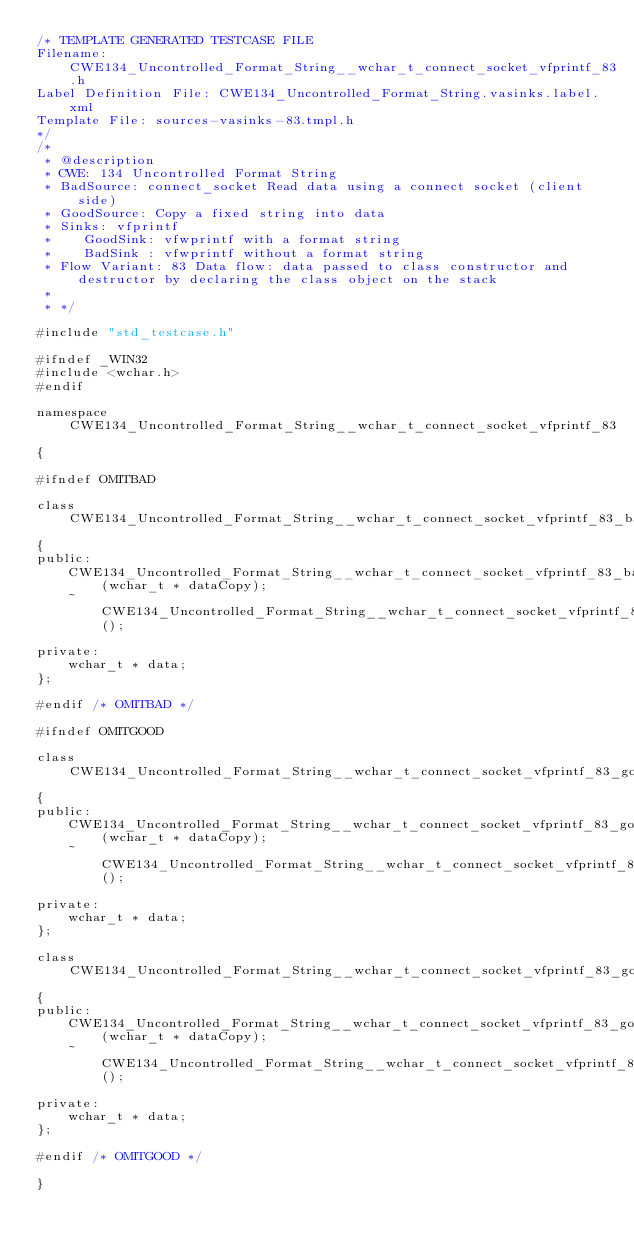<code> <loc_0><loc_0><loc_500><loc_500><_C_>/* TEMPLATE GENERATED TESTCASE FILE
Filename: CWE134_Uncontrolled_Format_String__wchar_t_connect_socket_vfprintf_83.h
Label Definition File: CWE134_Uncontrolled_Format_String.vasinks.label.xml
Template File: sources-vasinks-83.tmpl.h
*/
/*
 * @description
 * CWE: 134 Uncontrolled Format String
 * BadSource: connect_socket Read data using a connect socket (client side)
 * GoodSource: Copy a fixed string into data
 * Sinks: vfprintf
 *    GoodSink: vfwprintf with a format string
 *    BadSink : vfwprintf without a format string
 * Flow Variant: 83 Data flow: data passed to class constructor and destructor by declaring the class object on the stack
 *
 * */

#include "std_testcase.h"

#ifndef _WIN32
#include <wchar.h>
#endif

namespace CWE134_Uncontrolled_Format_String__wchar_t_connect_socket_vfprintf_83
{

#ifndef OMITBAD

class CWE134_Uncontrolled_Format_String__wchar_t_connect_socket_vfprintf_83_bad
{
public:
    CWE134_Uncontrolled_Format_String__wchar_t_connect_socket_vfprintf_83_bad(wchar_t * dataCopy);
    ~CWE134_Uncontrolled_Format_String__wchar_t_connect_socket_vfprintf_83_bad();

private:
    wchar_t * data;
};

#endif /* OMITBAD */

#ifndef OMITGOOD

class CWE134_Uncontrolled_Format_String__wchar_t_connect_socket_vfprintf_83_goodG2B
{
public:
    CWE134_Uncontrolled_Format_String__wchar_t_connect_socket_vfprintf_83_goodG2B(wchar_t * dataCopy);
    ~CWE134_Uncontrolled_Format_String__wchar_t_connect_socket_vfprintf_83_goodG2B();

private:
    wchar_t * data;
};

class CWE134_Uncontrolled_Format_String__wchar_t_connect_socket_vfprintf_83_goodB2G
{
public:
    CWE134_Uncontrolled_Format_String__wchar_t_connect_socket_vfprintf_83_goodB2G(wchar_t * dataCopy);
    ~CWE134_Uncontrolled_Format_String__wchar_t_connect_socket_vfprintf_83_goodB2G();

private:
    wchar_t * data;
};

#endif /* OMITGOOD */

}
</code> 